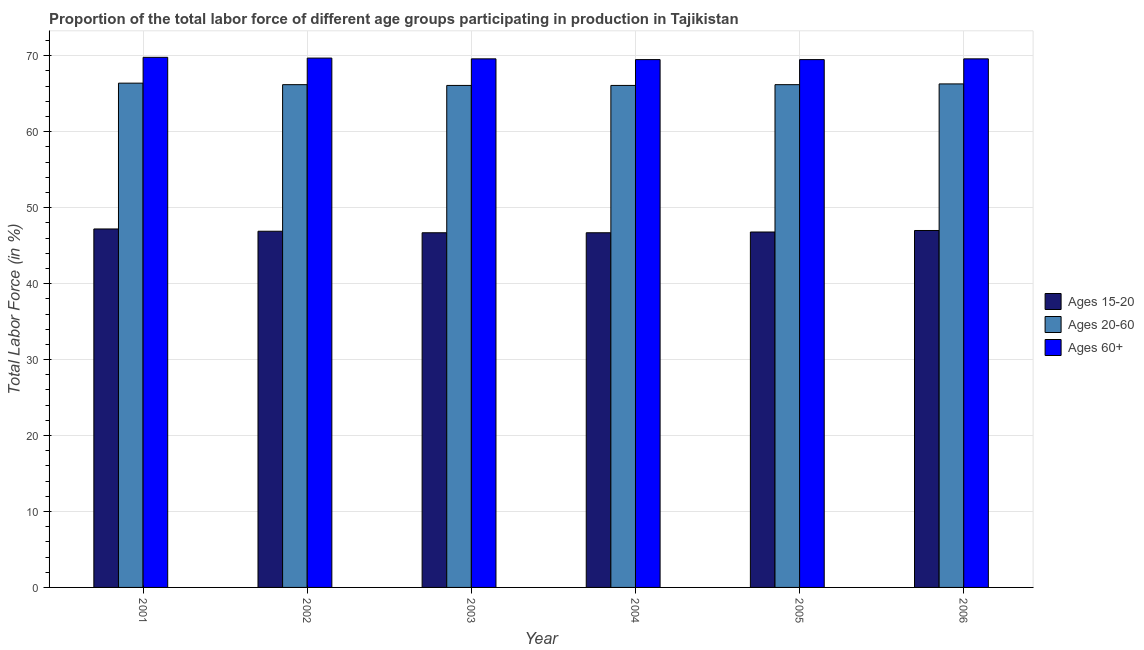Are the number of bars on each tick of the X-axis equal?
Your response must be concise. Yes. How many bars are there on the 3rd tick from the left?
Keep it short and to the point. 3. How many bars are there on the 5th tick from the right?
Provide a succinct answer. 3. What is the percentage of labor force above age 60 in 2003?
Offer a terse response. 69.6. Across all years, what is the maximum percentage of labor force above age 60?
Make the answer very short. 69.8. Across all years, what is the minimum percentage of labor force within the age group 15-20?
Ensure brevity in your answer.  46.7. What is the total percentage of labor force above age 60 in the graph?
Your answer should be compact. 417.7. What is the difference between the percentage of labor force above age 60 in 2003 and that in 2005?
Your answer should be very brief. 0.1. What is the average percentage of labor force above age 60 per year?
Keep it short and to the point. 69.62. In the year 2003, what is the difference between the percentage of labor force above age 60 and percentage of labor force within the age group 15-20?
Ensure brevity in your answer.  0. In how many years, is the percentage of labor force within the age group 20-60 greater than 46 %?
Ensure brevity in your answer.  6. What is the ratio of the percentage of labor force within the age group 15-20 in 2002 to that in 2004?
Offer a terse response. 1. Is the percentage of labor force within the age group 20-60 in 2005 less than that in 2006?
Your answer should be compact. Yes. Is the difference between the percentage of labor force above age 60 in 2001 and 2006 greater than the difference between the percentage of labor force within the age group 20-60 in 2001 and 2006?
Make the answer very short. No. What is the difference between the highest and the second highest percentage of labor force within the age group 20-60?
Your answer should be very brief. 0.1. What is the difference between the highest and the lowest percentage of labor force above age 60?
Provide a succinct answer. 0.3. In how many years, is the percentage of labor force above age 60 greater than the average percentage of labor force above age 60 taken over all years?
Make the answer very short. 2. What does the 2nd bar from the left in 2006 represents?
Make the answer very short. Ages 20-60. What does the 2nd bar from the right in 2006 represents?
Give a very brief answer. Ages 20-60. How many years are there in the graph?
Your answer should be very brief. 6. Does the graph contain any zero values?
Your response must be concise. No. How are the legend labels stacked?
Your answer should be very brief. Vertical. What is the title of the graph?
Your response must be concise. Proportion of the total labor force of different age groups participating in production in Tajikistan. Does "Manufactures" appear as one of the legend labels in the graph?
Your answer should be very brief. No. What is the label or title of the X-axis?
Ensure brevity in your answer.  Year. What is the label or title of the Y-axis?
Ensure brevity in your answer.  Total Labor Force (in %). What is the Total Labor Force (in %) in Ages 15-20 in 2001?
Keep it short and to the point. 47.2. What is the Total Labor Force (in %) of Ages 20-60 in 2001?
Offer a very short reply. 66.4. What is the Total Labor Force (in %) in Ages 60+ in 2001?
Make the answer very short. 69.8. What is the Total Labor Force (in %) of Ages 15-20 in 2002?
Give a very brief answer. 46.9. What is the Total Labor Force (in %) of Ages 20-60 in 2002?
Your response must be concise. 66.2. What is the Total Labor Force (in %) in Ages 60+ in 2002?
Provide a short and direct response. 69.7. What is the Total Labor Force (in %) in Ages 15-20 in 2003?
Ensure brevity in your answer.  46.7. What is the Total Labor Force (in %) of Ages 20-60 in 2003?
Your answer should be very brief. 66.1. What is the Total Labor Force (in %) in Ages 60+ in 2003?
Your response must be concise. 69.6. What is the Total Labor Force (in %) in Ages 15-20 in 2004?
Provide a short and direct response. 46.7. What is the Total Labor Force (in %) of Ages 20-60 in 2004?
Your answer should be very brief. 66.1. What is the Total Labor Force (in %) of Ages 60+ in 2004?
Keep it short and to the point. 69.5. What is the Total Labor Force (in %) in Ages 15-20 in 2005?
Offer a terse response. 46.8. What is the Total Labor Force (in %) in Ages 20-60 in 2005?
Your response must be concise. 66.2. What is the Total Labor Force (in %) in Ages 60+ in 2005?
Keep it short and to the point. 69.5. What is the Total Labor Force (in %) in Ages 20-60 in 2006?
Your answer should be very brief. 66.3. What is the Total Labor Force (in %) in Ages 60+ in 2006?
Keep it short and to the point. 69.6. Across all years, what is the maximum Total Labor Force (in %) of Ages 15-20?
Keep it short and to the point. 47.2. Across all years, what is the maximum Total Labor Force (in %) in Ages 20-60?
Your answer should be very brief. 66.4. Across all years, what is the maximum Total Labor Force (in %) of Ages 60+?
Offer a very short reply. 69.8. Across all years, what is the minimum Total Labor Force (in %) of Ages 15-20?
Ensure brevity in your answer.  46.7. Across all years, what is the minimum Total Labor Force (in %) of Ages 20-60?
Provide a succinct answer. 66.1. Across all years, what is the minimum Total Labor Force (in %) of Ages 60+?
Offer a terse response. 69.5. What is the total Total Labor Force (in %) in Ages 15-20 in the graph?
Your answer should be very brief. 281.3. What is the total Total Labor Force (in %) of Ages 20-60 in the graph?
Provide a short and direct response. 397.3. What is the total Total Labor Force (in %) in Ages 60+ in the graph?
Provide a succinct answer. 417.7. What is the difference between the Total Labor Force (in %) of Ages 20-60 in 2001 and that in 2002?
Your response must be concise. 0.2. What is the difference between the Total Labor Force (in %) in Ages 60+ in 2001 and that in 2003?
Offer a terse response. 0.2. What is the difference between the Total Labor Force (in %) in Ages 15-20 in 2001 and that in 2004?
Ensure brevity in your answer.  0.5. What is the difference between the Total Labor Force (in %) of Ages 60+ in 2001 and that in 2004?
Offer a very short reply. 0.3. What is the difference between the Total Labor Force (in %) in Ages 15-20 in 2001 and that in 2005?
Provide a short and direct response. 0.4. What is the difference between the Total Labor Force (in %) of Ages 15-20 in 2001 and that in 2006?
Your answer should be very brief. 0.2. What is the difference between the Total Labor Force (in %) of Ages 60+ in 2001 and that in 2006?
Provide a short and direct response. 0.2. What is the difference between the Total Labor Force (in %) in Ages 20-60 in 2002 and that in 2003?
Provide a short and direct response. 0.1. What is the difference between the Total Labor Force (in %) in Ages 60+ in 2002 and that in 2003?
Provide a succinct answer. 0.1. What is the difference between the Total Labor Force (in %) in Ages 20-60 in 2002 and that in 2004?
Keep it short and to the point. 0.1. What is the difference between the Total Labor Force (in %) of Ages 60+ in 2002 and that in 2004?
Give a very brief answer. 0.2. What is the difference between the Total Labor Force (in %) of Ages 60+ in 2002 and that in 2005?
Ensure brevity in your answer.  0.2. What is the difference between the Total Labor Force (in %) in Ages 20-60 in 2003 and that in 2004?
Your answer should be very brief. 0. What is the difference between the Total Labor Force (in %) of Ages 60+ in 2003 and that in 2004?
Ensure brevity in your answer.  0.1. What is the difference between the Total Labor Force (in %) of Ages 60+ in 2003 and that in 2005?
Your answer should be compact. 0.1. What is the difference between the Total Labor Force (in %) of Ages 15-20 in 2003 and that in 2006?
Offer a very short reply. -0.3. What is the difference between the Total Labor Force (in %) in Ages 20-60 in 2003 and that in 2006?
Offer a terse response. -0.2. What is the difference between the Total Labor Force (in %) of Ages 60+ in 2003 and that in 2006?
Provide a short and direct response. 0. What is the difference between the Total Labor Force (in %) of Ages 20-60 in 2004 and that in 2005?
Your response must be concise. -0.1. What is the difference between the Total Labor Force (in %) of Ages 15-20 in 2001 and the Total Labor Force (in %) of Ages 20-60 in 2002?
Keep it short and to the point. -19. What is the difference between the Total Labor Force (in %) in Ages 15-20 in 2001 and the Total Labor Force (in %) in Ages 60+ in 2002?
Provide a succinct answer. -22.5. What is the difference between the Total Labor Force (in %) in Ages 15-20 in 2001 and the Total Labor Force (in %) in Ages 20-60 in 2003?
Your response must be concise. -18.9. What is the difference between the Total Labor Force (in %) of Ages 15-20 in 2001 and the Total Labor Force (in %) of Ages 60+ in 2003?
Keep it short and to the point. -22.4. What is the difference between the Total Labor Force (in %) in Ages 15-20 in 2001 and the Total Labor Force (in %) in Ages 20-60 in 2004?
Your answer should be compact. -18.9. What is the difference between the Total Labor Force (in %) in Ages 15-20 in 2001 and the Total Labor Force (in %) in Ages 60+ in 2004?
Your response must be concise. -22.3. What is the difference between the Total Labor Force (in %) of Ages 15-20 in 2001 and the Total Labor Force (in %) of Ages 60+ in 2005?
Give a very brief answer. -22.3. What is the difference between the Total Labor Force (in %) in Ages 15-20 in 2001 and the Total Labor Force (in %) in Ages 20-60 in 2006?
Ensure brevity in your answer.  -19.1. What is the difference between the Total Labor Force (in %) in Ages 15-20 in 2001 and the Total Labor Force (in %) in Ages 60+ in 2006?
Your answer should be very brief. -22.4. What is the difference between the Total Labor Force (in %) in Ages 15-20 in 2002 and the Total Labor Force (in %) in Ages 20-60 in 2003?
Ensure brevity in your answer.  -19.2. What is the difference between the Total Labor Force (in %) in Ages 15-20 in 2002 and the Total Labor Force (in %) in Ages 60+ in 2003?
Your answer should be very brief. -22.7. What is the difference between the Total Labor Force (in %) of Ages 15-20 in 2002 and the Total Labor Force (in %) of Ages 20-60 in 2004?
Your answer should be very brief. -19.2. What is the difference between the Total Labor Force (in %) in Ages 15-20 in 2002 and the Total Labor Force (in %) in Ages 60+ in 2004?
Keep it short and to the point. -22.6. What is the difference between the Total Labor Force (in %) in Ages 20-60 in 2002 and the Total Labor Force (in %) in Ages 60+ in 2004?
Provide a short and direct response. -3.3. What is the difference between the Total Labor Force (in %) in Ages 15-20 in 2002 and the Total Labor Force (in %) in Ages 20-60 in 2005?
Provide a short and direct response. -19.3. What is the difference between the Total Labor Force (in %) of Ages 15-20 in 2002 and the Total Labor Force (in %) of Ages 60+ in 2005?
Provide a succinct answer. -22.6. What is the difference between the Total Labor Force (in %) of Ages 15-20 in 2002 and the Total Labor Force (in %) of Ages 20-60 in 2006?
Keep it short and to the point. -19.4. What is the difference between the Total Labor Force (in %) in Ages 15-20 in 2002 and the Total Labor Force (in %) in Ages 60+ in 2006?
Your answer should be very brief. -22.7. What is the difference between the Total Labor Force (in %) of Ages 15-20 in 2003 and the Total Labor Force (in %) of Ages 20-60 in 2004?
Offer a very short reply. -19.4. What is the difference between the Total Labor Force (in %) of Ages 15-20 in 2003 and the Total Labor Force (in %) of Ages 60+ in 2004?
Offer a terse response. -22.8. What is the difference between the Total Labor Force (in %) of Ages 15-20 in 2003 and the Total Labor Force (in %) of Ages 20-60 in 2005?
Your answer should be compact. -19.5. What is the difference between the Total Labor Force (in %) of Ages 15-20 in 2003 and the Total Labor Force (in %) of Ages 60+ in 2005?
Keep it short and to the point. -22.8. What is the difference between the Total Labor Force (in %) of Ages 15-20 in 2003 and the Total Labor Force (in %) of Ages 20-60 in 2006?
Your response must be concise. -19.6. What is the difference between the Total Labor Force (in %) of Ages 15-20 in 2003 and the Total Labor Force (in %) of Ages 60+ in 2006?
Make the answer very short. -22.9. What is the difference between the Total Labor Force (in %) of Ages 15-20 in 2004 and the Total Labor Force (in %) of Ages 20-60 in 2005?
Offer a very short reply. -19.5. What is the difference between the Total Labor Force (in %) of Ages 15-20 in 2004 and the Total Labor Force (in %) of Ages 60+ in 2005?
Your answer should be very brief. -22.8. What is the difference between the Total Labor Force (in %) of Ages 15-20 in 2004 and the Total Labor Force (in %) of Ages 20-60 in 2006?
Your answer should be very brief. -19.6. What is the difference between the Total Labor Force (in %) of Ages 15-20 in 2004 and the Total Labor Force (in %) of Ages 60+ in 2006?
Provide a succinct answer. -22.9. What is the difference between the Total Labor Force (in %) of Ages 15-20 in 2005 and the Total Labor Force (in %) of Ages 20-60 in 2006?
Offer a terse response. -19.5. What is the difference between the Total Labor Force (in %) of Ages 15-20 in 2005 and the Total Labor Force (in %) of Ages 60+ in 2006?
Keep it short and to the point. -22.8. What is the average Total Labor Force (in %) in Ages 15-20 per year?
Your response must be concise. 46.88. What is the average Total Labor Force (in %) of Ages 20-60 per year?
Make the answer very short. 66.22. What is the average Total Labor Force (in %) of Ages 60+ per year?
Your response must be concise. 69.62. In the year 2001, what is the difference between the Total Labor Force (in %) of Ages 15-20 and Total Labor Force (in %) of Ages 20-60?
Offer a terse response. -19.2. In the year 2001, what is the difference between the Total Labor Force (in %) of Ages 15-20 and Total Labor Force (in %) of Ages 60+?
Ensure brevity in your answer.  -22.6. In the year 2002, what is the difference between the Total Labor Force (in %) in Ages 15-20 and Total Labor Force (in %) in Ages 20-60?
Provide a short and direct response. -19.3. In the year 2002, what is the difference between the Total Labor Force (in %) of Ages 15-20 and Total Labor Force (in %) of Ages 60+?
Ensure brevity in your answer.  -22.8. In the year 2003, what is the difference between the Total Labor Force (in %) of Ages 15-20 and Total Labor Force (in %) of Ages 20-60?
Your response must be concise. -19.4. In the year 2003, what is the difference between the Total Labor Force (in %) in Ages 15-20 and Total Labor Force (in %) in Ages 60+?
Keep it short and to the point. -22.9. In the year 2003, what is the difference between the Total Labor Force (in %) of Ages 20-60 and Total Labor Force (in %) of Ages 60+?
Make the answer very short. -3.5. In the year 2004, what is the difference between the Total Labor Force (in %) in Ages 15-20 and Total Labor Force (in %) in Ages 20-60?
Offer a very short reply. -19.4. In the year 2004, what is the difference between the Total Labor Force (in %) in Ages 15-20 and Total Labor Force (in %) in Ages 60+?
Your response must be concise. -22.8. In the year 2004, what is the difference between the Total Labor Force (in %) in Ages 20-60 and Total Labor Force (in %) in Ages 60+?
Offer a very short reply. -3.4. In the year 2005, what is the difference between the Total Labor Force (in %) of Ages 15-20 and Total Labor Force (in %) of Ages 20-60?
Offer a very short reply. -19.4. In the year 2005, what is the difference between the Total Labor Force (in %) of Ages 15-20 and Total Labor Force (in %) of Ages 60+?
Your answer should be compact. -22.7. In the year 2005, what is the difference between the Total Labor Force (in %) of Ages 20-60 and Total Labor Force (in %) of Ages 60+?
Keep it short and to the point. -3.3. In the year 2006, what is the difference between the Total Labor Force (in %) in Ages 15-20 and Total Labor Force (in %) in Ages 20-60?
Offer a very short reply. -19.3. In the year 2006, what is the difference between the Total Labor Force (in %) in Ages 15-20 and Total Labor Force (in %) in Ages 60+?
Your answer should be compact. -22.6. In the year 2006, what is the difference between the Total Labor Force (in %) of Ages 20-60 and Total Labor Force (in %) of Ages 60+?
Provide a succinct answer. -3.3. What is the ratio of the Total Labor Force (in %) in Ages 15-20 in 2001 to that in 2002?
Keep it short and to the point. 1.01. What is the ratio of the Total Labor Force (in %) in Ages 20-60 in 2001 to that in 2002?
Ensure brevity in your answer.  1. What is the ratio of the Total Labor Force (in %) in Ages 15-20 in 2001 to that in 2003?
Your answer should be compact. 1.01. What is the ratio of the Total Labor Force (in %) of Ages 60+ in 2001 to that in 2003?
Your answer should be very brief. 1. What is the ratio of the Total Labor Force (in %) of Ages 15-20 in 2001 to that in 2004?
Make the answer very short. 1.01. What is the ratio of the Total Labor Force (in %) in Ages 20-60 in 2001 to that in 2004?
Keep it short and to the point. 1. What is the ratio of the Total Labor Force (in %) in Ages 15-20 in 2001 to that in 2005?
Offer a very short reply. 1.01. What is the ratio of the Total Labor Force (in %) of Ages 60+ in 2001 to that in 2005?
Provide a short and direct response. 1. What is the ratio of the Total Labor Force (in %) of Ages 15-20 in 2001 to that in 2006?
Ensure brevity in your answer.  1. What is the ratio of the Total Labor Force (in %) in Ages 60+ in 2001 to that in 2006?
Give a very brief answer. 1. What is the ratio of the Total Labor Force (in %) in Ages 15-20 in 2002 to that in 2003?
Your response must be concise. 1. What is the ratio of the Total Labor Force (in %) in Ages 20-60 in 2002 to that in 2003?
Provide a short and direct response. 1. What is the ratio of the Total Labor Force (in %) of Ages 60+ in 2002 to that in 2003?
Offer a very short reply. 1. What is the ratio of the Total Labor Force (in %) in Ages 15-20 in 2002 to that in 2004?
Your answer should be compact. 1. What is the ratio of the Total Labor Force (in %) in Ages 20-60 in 2002 to that in 2005?
Offer a terse response. 1. What is the ratio of the Total Labor Force (in %) in Ages 60+ in 2002 to that in 2005?
Your answer should be very brief. 1. What is the ratio of the Total Labor Force (in %) in Ages 15-20 in 2002 to that in 2006?
Provide a short and direct response. 1. What is the ratio of the Total Labor Force (in %) in Ages 20-60 in 2002 to that in 2006?
Offer a terse response. 1. What is the ratio of the Total Labor Force (in %) in Ages 15-20 in 2003 to that in 2004?
Offer a very short reply. 1. What is the ratio of the Total Labor Force (in %) of Ages 60+ in 2003 to that in 2004?
Offer a terse response. 1. What is the ratio of the Total Labor Force (in %) in Ages 15-20 in 2003 to that in 2005?
Ensure brevity in your answer.  1. What is the ratio of the Total Labor Force (in %) in Ages 20-60 in 2003 to that in 2005?
Make the answer very short. 1. What is the ratio of the Total Labor Force (in %) of Ages 60+ in 2003 to that in 2005?
Your answer should be very brief. 1. What is the ratio of the Total Labor Force (in %) in Ages 15-20 in 2003 to that in 2006?
Ensure brevity in your answer.  0.99. What is the ratio of the Total Labor Force (in %) in Ages 20-60 in 2004 to that in 2005?
Offer a terse response. 1. What is the ratio of the Total Labor Force (in %) of Ages 60+ in 2004 to that in 2005?
Offer a terse response. 1. What is the ratio of the Total Labor Force (in %) in Ages 15-20 in 2004 to that in 2006?
Keep it short and to the point. 0.99. What is the ratio of the Total Labor Force (in %) of Ages 60+ in 2004 to that in 2006?
Provide a succinct answer. 1. What is the ratio of the Total Labor Force (in %) of Ages 15-20 in 2005 to that in 2006?
Make the answer very short. 1. What is the ratio of the Total Labor Force (in %) in Ages 20-60 in 2005 to that in 2006?
Provide a succinct answer. 1. What is the ratio of the Total Labor Force (in %) in Ages 60+ in 2005 to that in 2006?
Offer a terse response. 1. What is the difference between the highest and the second highest Total Labor Force (in %) of Ages 20-60?
Ensure brevity in your answer.  0.1. What is the difference between the highest and the lowest Total Labor Force (in %) in Ages 15-20?
Keep it short and to the point. 0.5. 